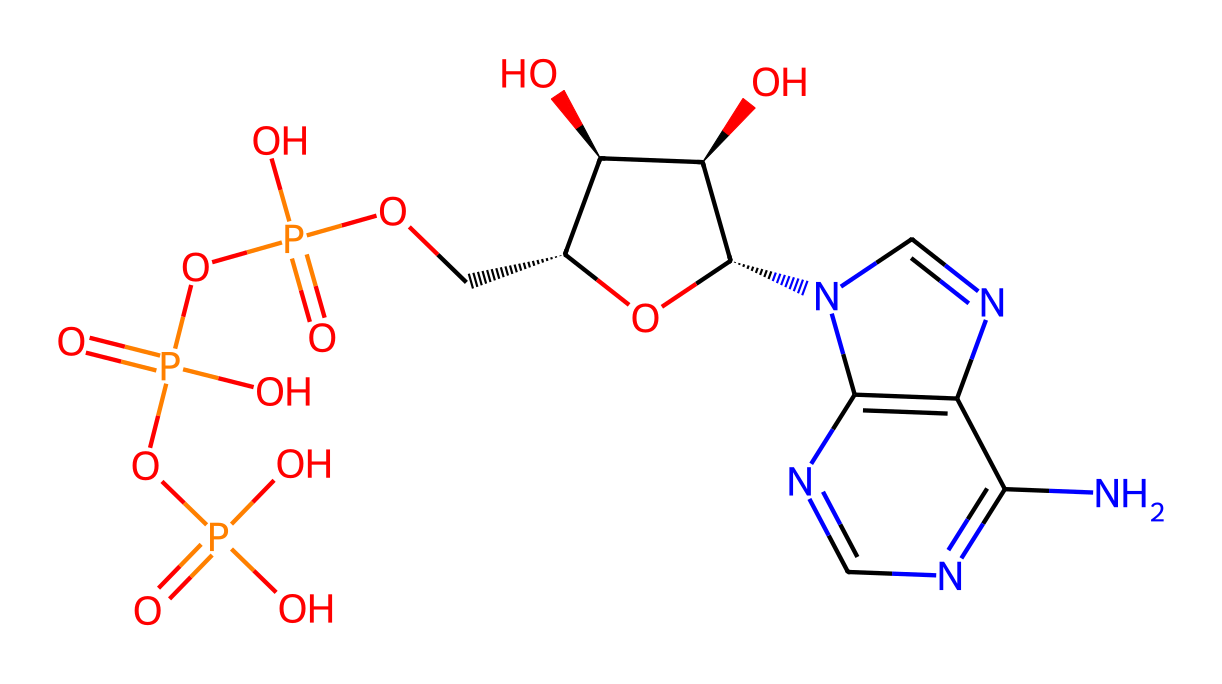What is the molecular formula of ATP? The molecular composition can be derived from the counts of different atoms in the chemical structure. In the provided SMILES, we have 10 carbon (C) atoms, 13 hydrogen (H) atoms, 5 nitrogen (N) atoms, 1 phosphorus (P) atom, and 4 oxygen (O) atoms. This leads to the molecular formula of C10H13N5O4P.
Answer: C10H13N5O4P How many phosphate groups are present in ATP? By examining the structure, we can see that ATP contains three phosphate groups indicated by the presence of the 'OP(=O)(O)' sequences. Each of these sequences represents a phosphate group. Therefore, ATP has three phosphate groups.
Answer: 3 Which atoms in ATP carry negative charges? Looking closely at the phosphate groups in the structure, we can determine that the oxygens attached to the phosphorus atoms likely carry negative charges due to the oxidation state of phosphorus. Each phosphate group generally has at least one negatively charged oxygen atom. Therefore, ATP contains negatively charged oxygens.
Answer: oxygen What type of bond links the ribose sugar to the phosphate groups in ATP? Analyzing the structure, the connection between the ribose sugar and the phosphate groups can be identified as a phosphoester bond, which is formed through a condensation reaction between an alcohol group on the sugar and a phosphate group, characterizing the structure of ATP.
Answer: phosphoester bond What is the role of ATP in biological systems? ATP serves as the primary energy carrier in biological systems. The high-energy phosphate bonds (particularly between the second and third phosphate groups) are broken to release energy, which is utilized for various biochemical processes.
Answer: energy carrier How many hydrogen bonds can be formed with ATP? Assessing the molecular structure, we can infer that the nitrogen and oxygen atoms present in ATP can act as hydrogen bond donors or acceptors. In this compound, potential hydrogen bonding sites can be found with both nitrogen and oxygen, leading to several possibilities. However, a precise number may depend on the specific interactions with other molecules in biological systems.
Answer: multiple 